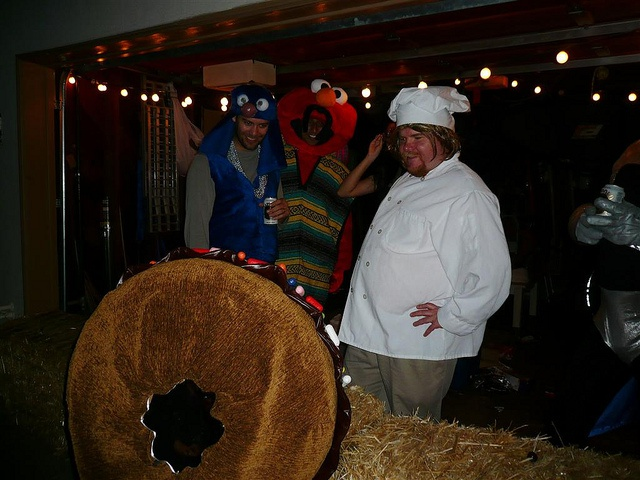Describe the objects in this image and their specific colors. I can see donut in black, maroon, and olive tones, people in black, darkgray, and gray tones, people in black, navy, maroon, and gray tones, people in black, maroon, and olive tones, and people in black, gray, purple, and darkgray tones in this image. 